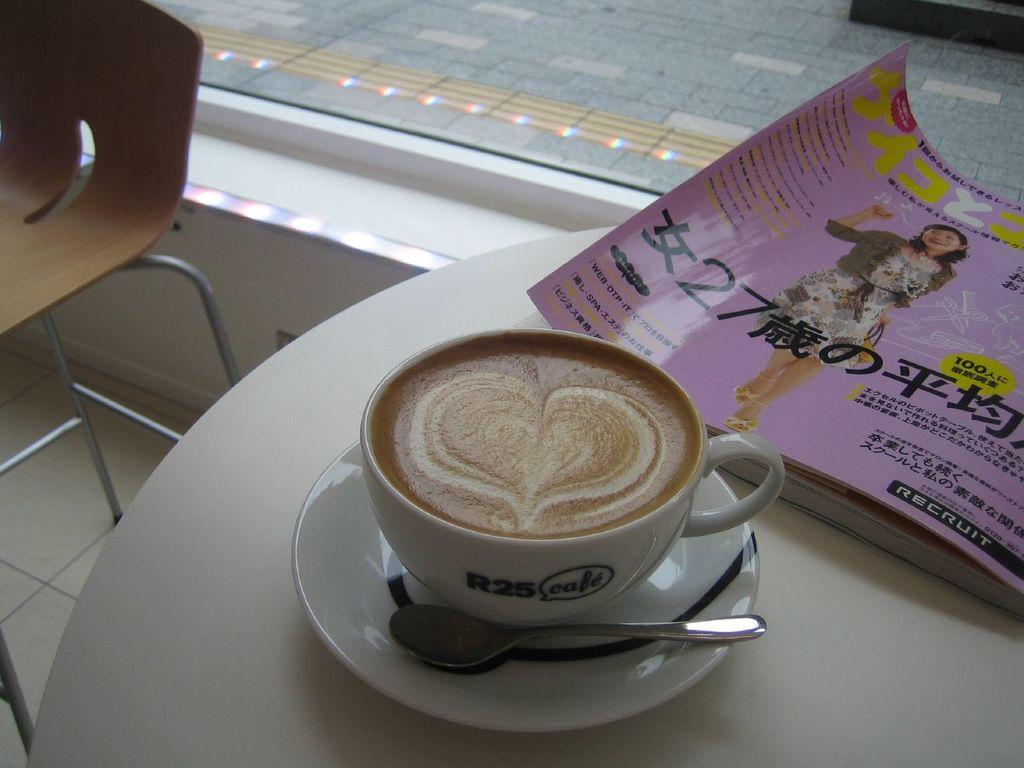What is one of the objects on the table in the image? There is a coffee cup in the image. What else can be seen on the table in the image? There is a spoon and a book on the table in the image. Can you describe the objects on the table? The coffee cup, spoon, and book are all on the table in the image. How many ants are crawling on the book in the image? There are no ants present in the image; it only shows a coffee cup, spoon, and book on a table. What type of rail can be seen in the image? There is no rail present in the image. 